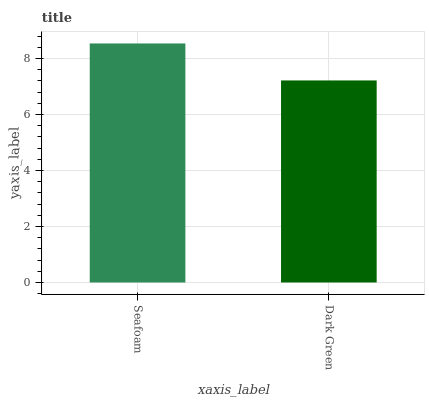Is Dark Green the minimum?
Answer yes or no. Yes. Is Seafoam the maximum?
Answer yes or no. Yes. Is Dark Green the maximum?
Answer yes or no. No. Is Seafoam greater than Dark Green?
Answer yes or no. Yes. Is Dark Green less than Seafoam?
Answer yes or no. Yes. Is Dark Green greater than Seafoam?
Answer yes or no. No. Is Seafoam less than Dark Green?
Answer yes or no. No. Is Seafoam the high median?
Answer yes or no. Yes. Is Dark Green the low median?
Answer yes or no. Yes. Is Dark Green the high median?
Answer yes or no. No. Is Seafoam the low median?
Answer yes or no. No. 